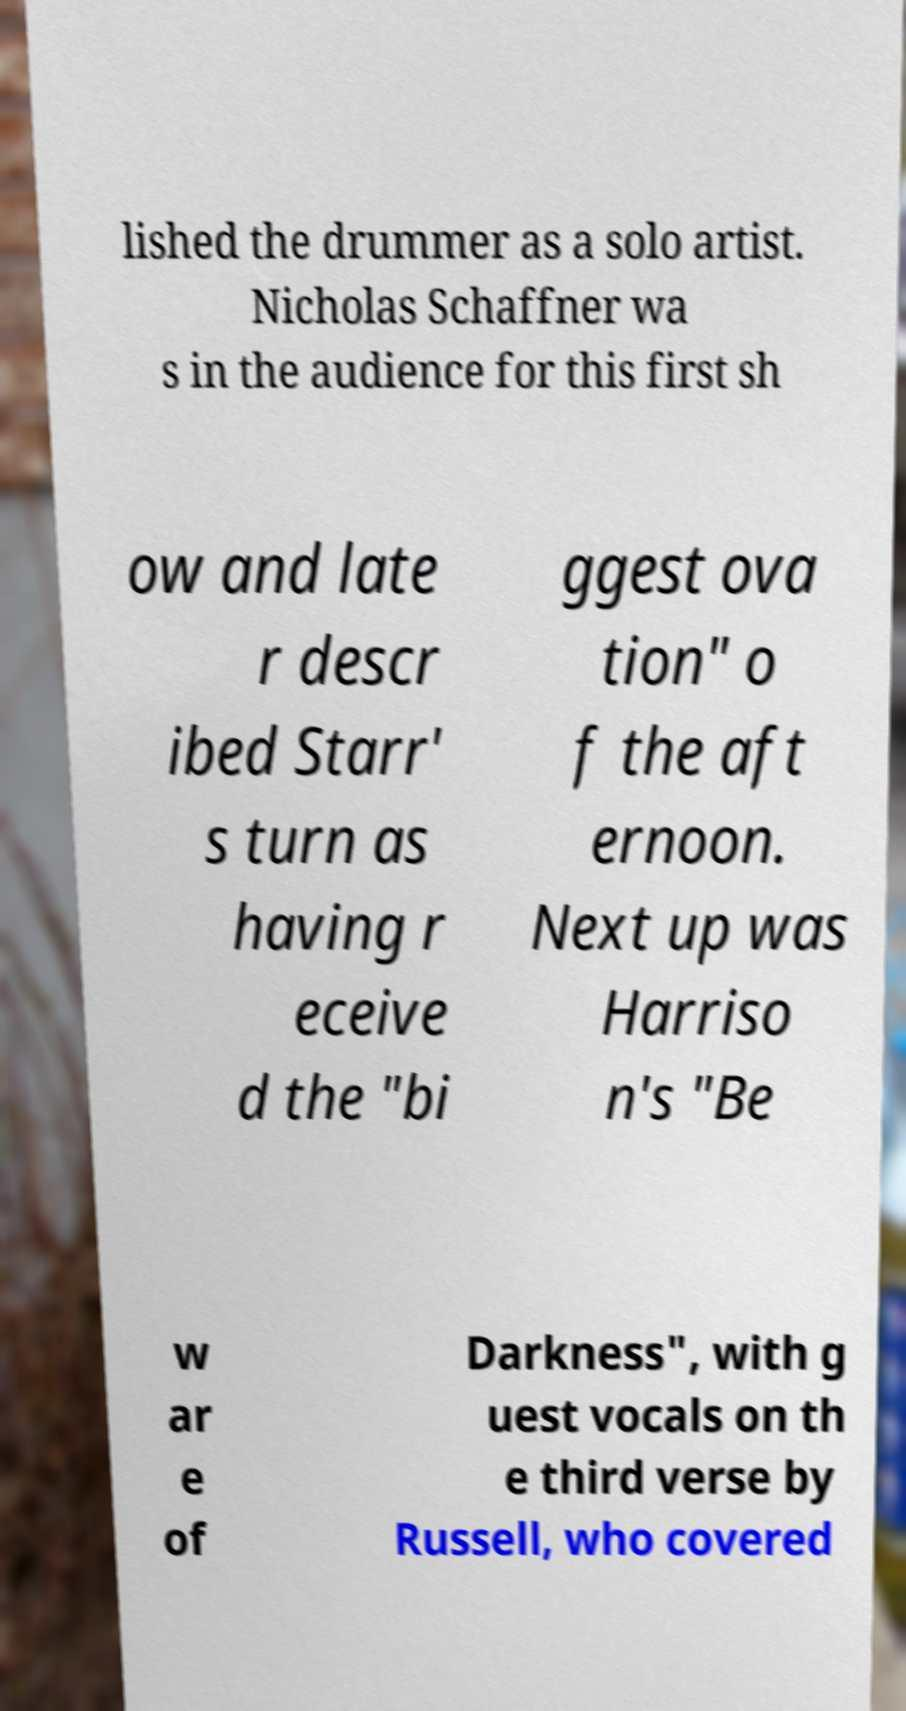What messages or text are displayed in this image? I need them in a readable, typed format. lished the drummer as a solo artist. Nicholas Schaffner wa s in the audience for this first sh ow and late r descr ibed Starr' s turn as having r eceive d the "bi ggest ova tion" o f the aft ernoon. Next up was Harriso n's "Be w ar e of Darkness", with g uest vocals on th e third verse by Russell, who covered 